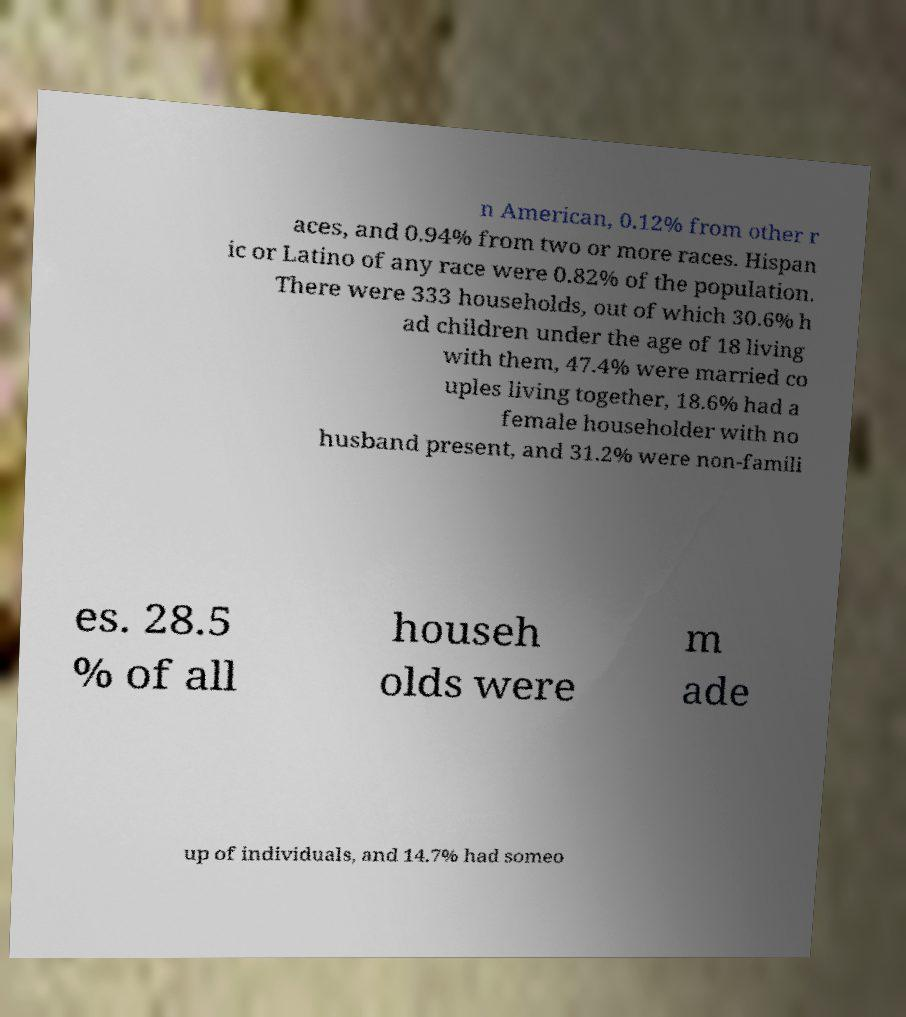I need the written content from this picture converted into text. Can you do that? n American, 0.12% from other r aces, and 0.94% from two or more races. Hispan ic or Latino of any race were 0.82% of the population. There were 333 households, out of which 30.6% h ad children under the age of 18 living with them, 47.4% were married co uples living together, 18.6% had a female householder with no husband present, and 31.2% were non-famili es. 28.5 % of all househ olds were m ade up of individuals, and 14.7% had someo 